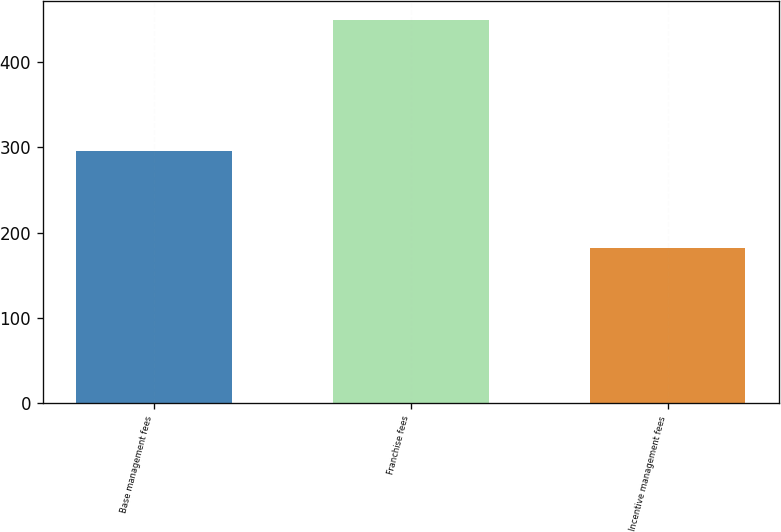Convert chart. <chart><loc_0><loc_0><loc_500><loc_500><bar_chart><fcel>Base management fees<fcel>Franchise fees<fcel>Incentive management fees<nl><fcel>296<fcel>449<fcel>182<nl></chart> 